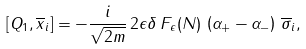<formula> <loc_0><loc_0><loc_500><loc_500>\left [ Q _ { 1 } , \overline { x } _ { i } \right ] = - \frac { i } { \sqrt { 2 m } } \, 2 \epsilon \delta \, F _ { \epsilon } ( N ) \, \left ( \alpha _ { + } - \alpha _ { - } \right ) \, \overline { \sigma } _ { i } ,</formula> 